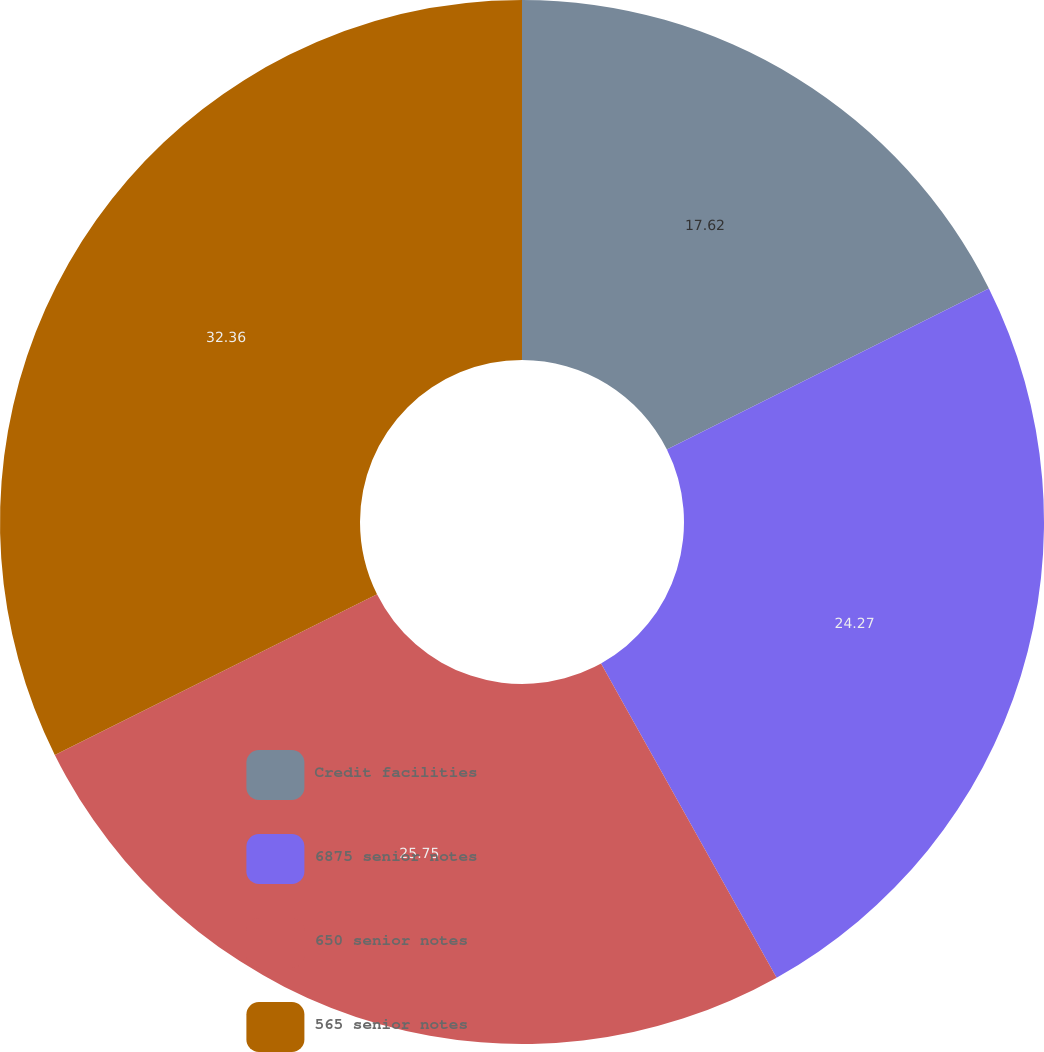Convert chart. <chart><loc_0><loc_0><loc_500><loc_500><pie_chart><fcel>Credit facilities<fcel>6875 senior notes<fcel>650 senior notes<fcel>565 senior notes<nl><fcel>17.62%<fcel>24.27%<fcel>25.75%<fcel>32.36%<nl></chart> 